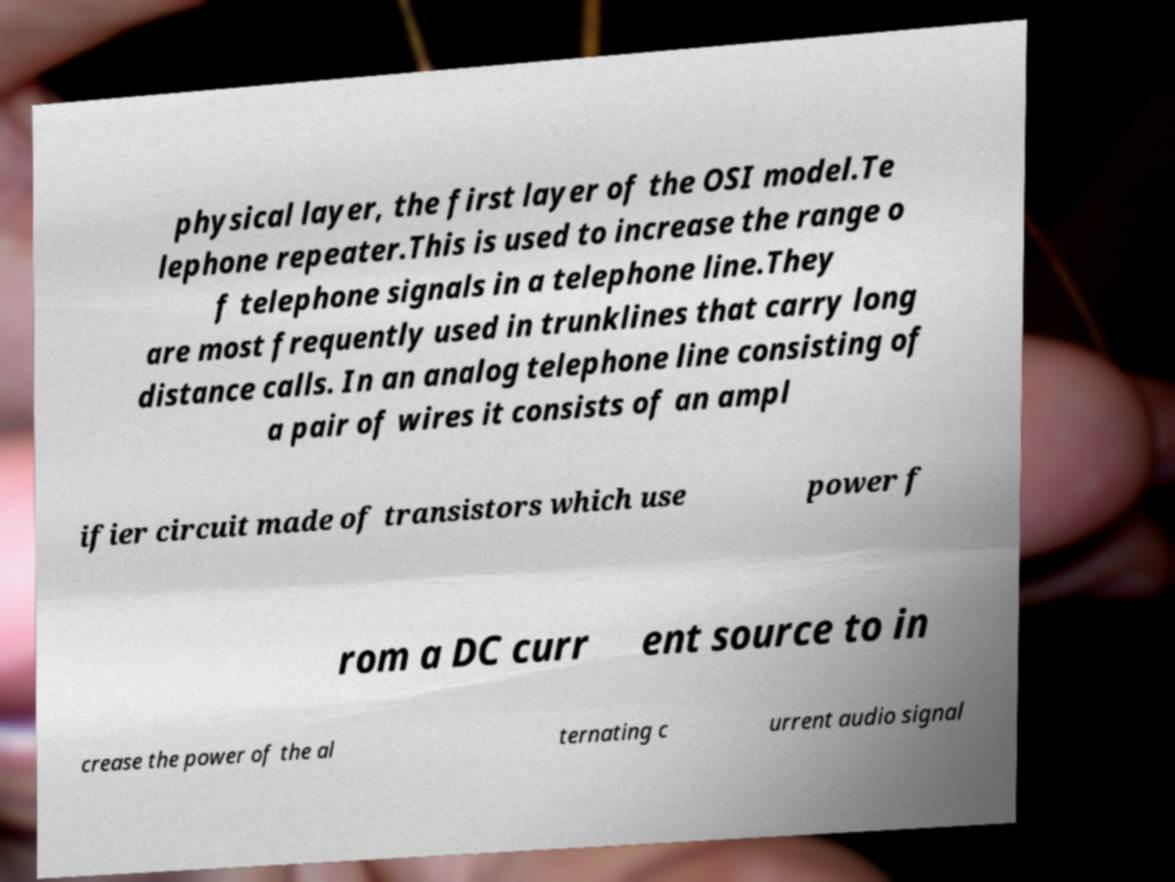Can you read and provide the text displayed in the image?This photo seems to have some interesting text. Can you extract and type it out for me? physical layer, the first layer of the OSI model.Te lephone repeater.This is used to increase the range o f telephone signals in a telephone line.They are most frequently used in trunklines that carry long distance calls. In an analog telephone line consisting of a pair of wires it consists of an ampl ifier circuit made of transistors which use power f rom a DC curr ent source to in crease the power of the al ternating c urrent audio signal 